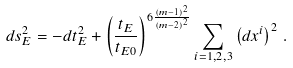Convert formula to latex. <formula><loc_0><loc_0><loc_500><loc_500>d s ^ { 2 } _ { E } = - d t _ { E } ^ { 2 } + \left ( \frac { t _ { E } } { t _ { E 0 } } \right ) ^ { 6 \frac { ( m - 1 ) ^ { 2 } } { ( m - 2 ) ^ { 2 } } } \sum _ { i = 1 , 2 , 3 } \left ( d x ^ { i } \right ) ^ { 2 } \, .</formula> 